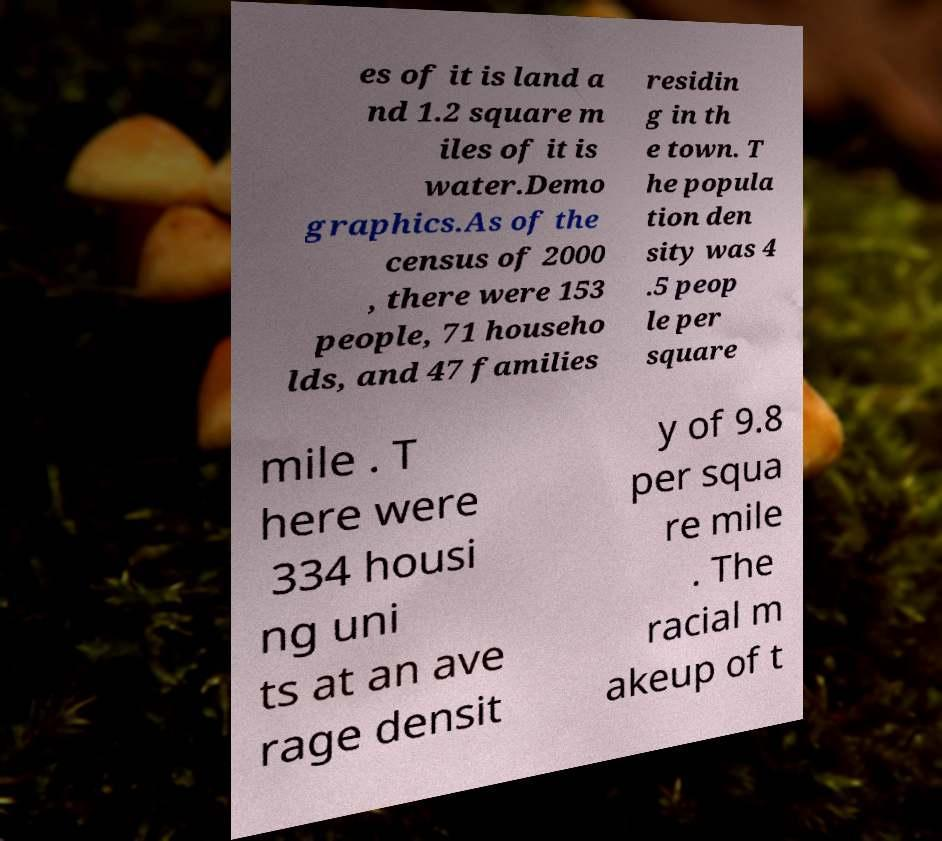What messages or text are displayed in this image? I need them in a readable, typed format. es of it is land a nd 1.2 square m iles of it is water.Demo graphics.As of the census of 2000 , there were 153 people, 71 househo lds, and 47 families residin g in th e town. T he popula tion den sity was 4 .5 peop le per square mile . T here were 334 housi ng uni ts at an ave rage densit y of 9.8 per squa re mile . The racial m akeup of t 